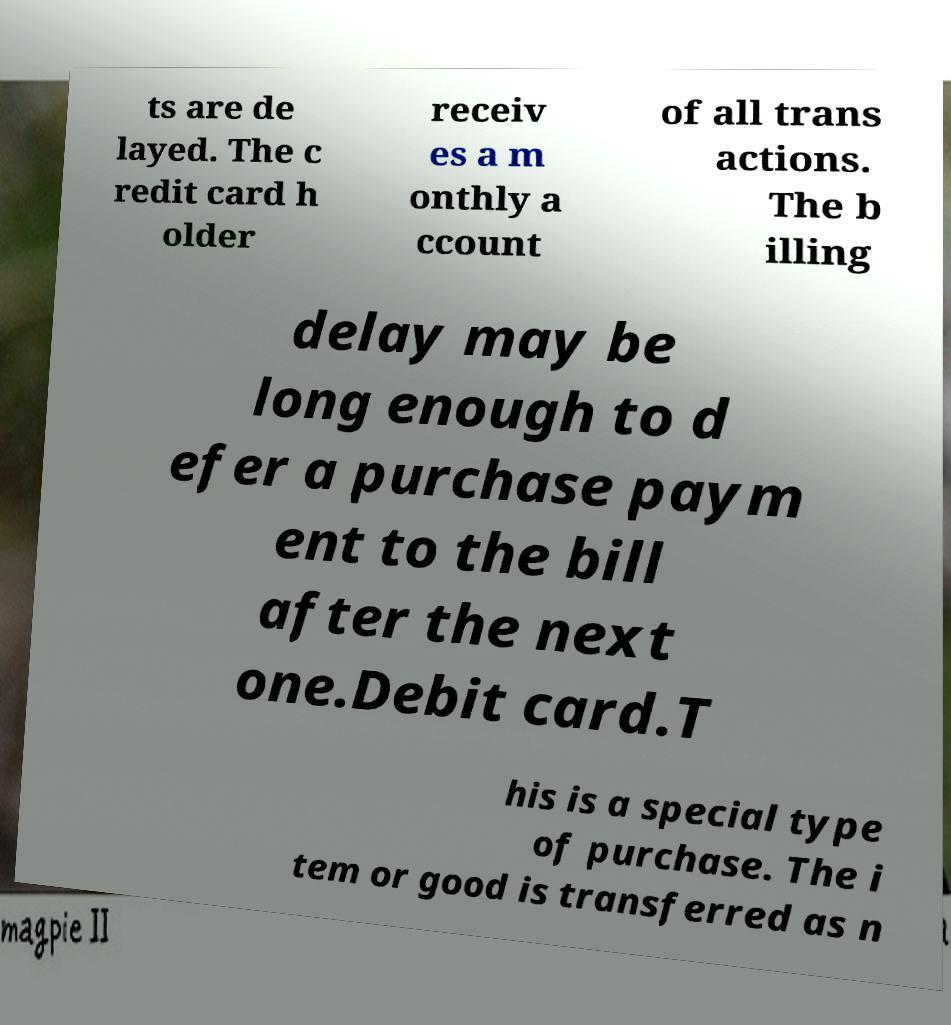What messages or text are displayed in this image? I need them in a readable, typed format. ts are de layed. The c redit card h older receiv es a m onthly a ccount of all trans actions. The b illing delay may be long enough to d efer a purchase paym ent to the bill after the next one.Debit card.T his is a special type of purchase. The i tem or good is transferred as n 